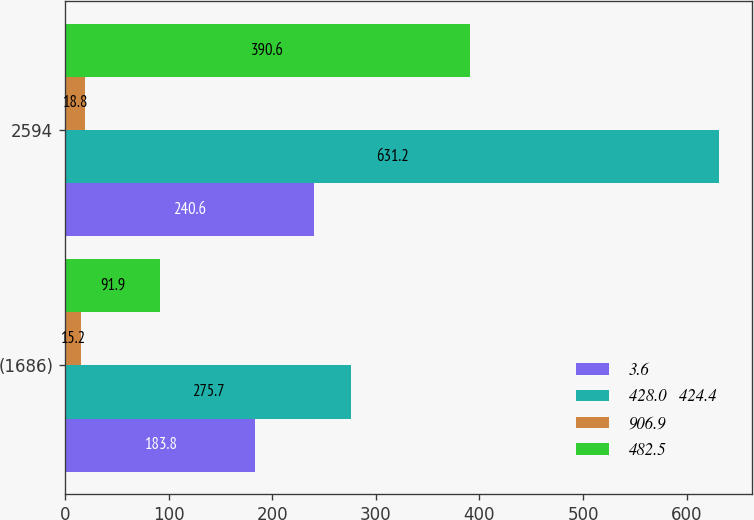Convert chart to OTSL. <chart><loc_0><loc_0><loc_500><loc_500><stacked_bar_chart><ecel><fcel>(1686)<fcel>2594<nl><fcel>3.6<fcel>183.8<fcel>240.6<nl><fcel>428.0   424.4<fcel>275.7<fcel>631.2<nl><fcel>906.9<fcel>15.2<fcel>18.8<nl><fcel>482.5<fcel>91.9<fcel>390.6<nl></chart> 